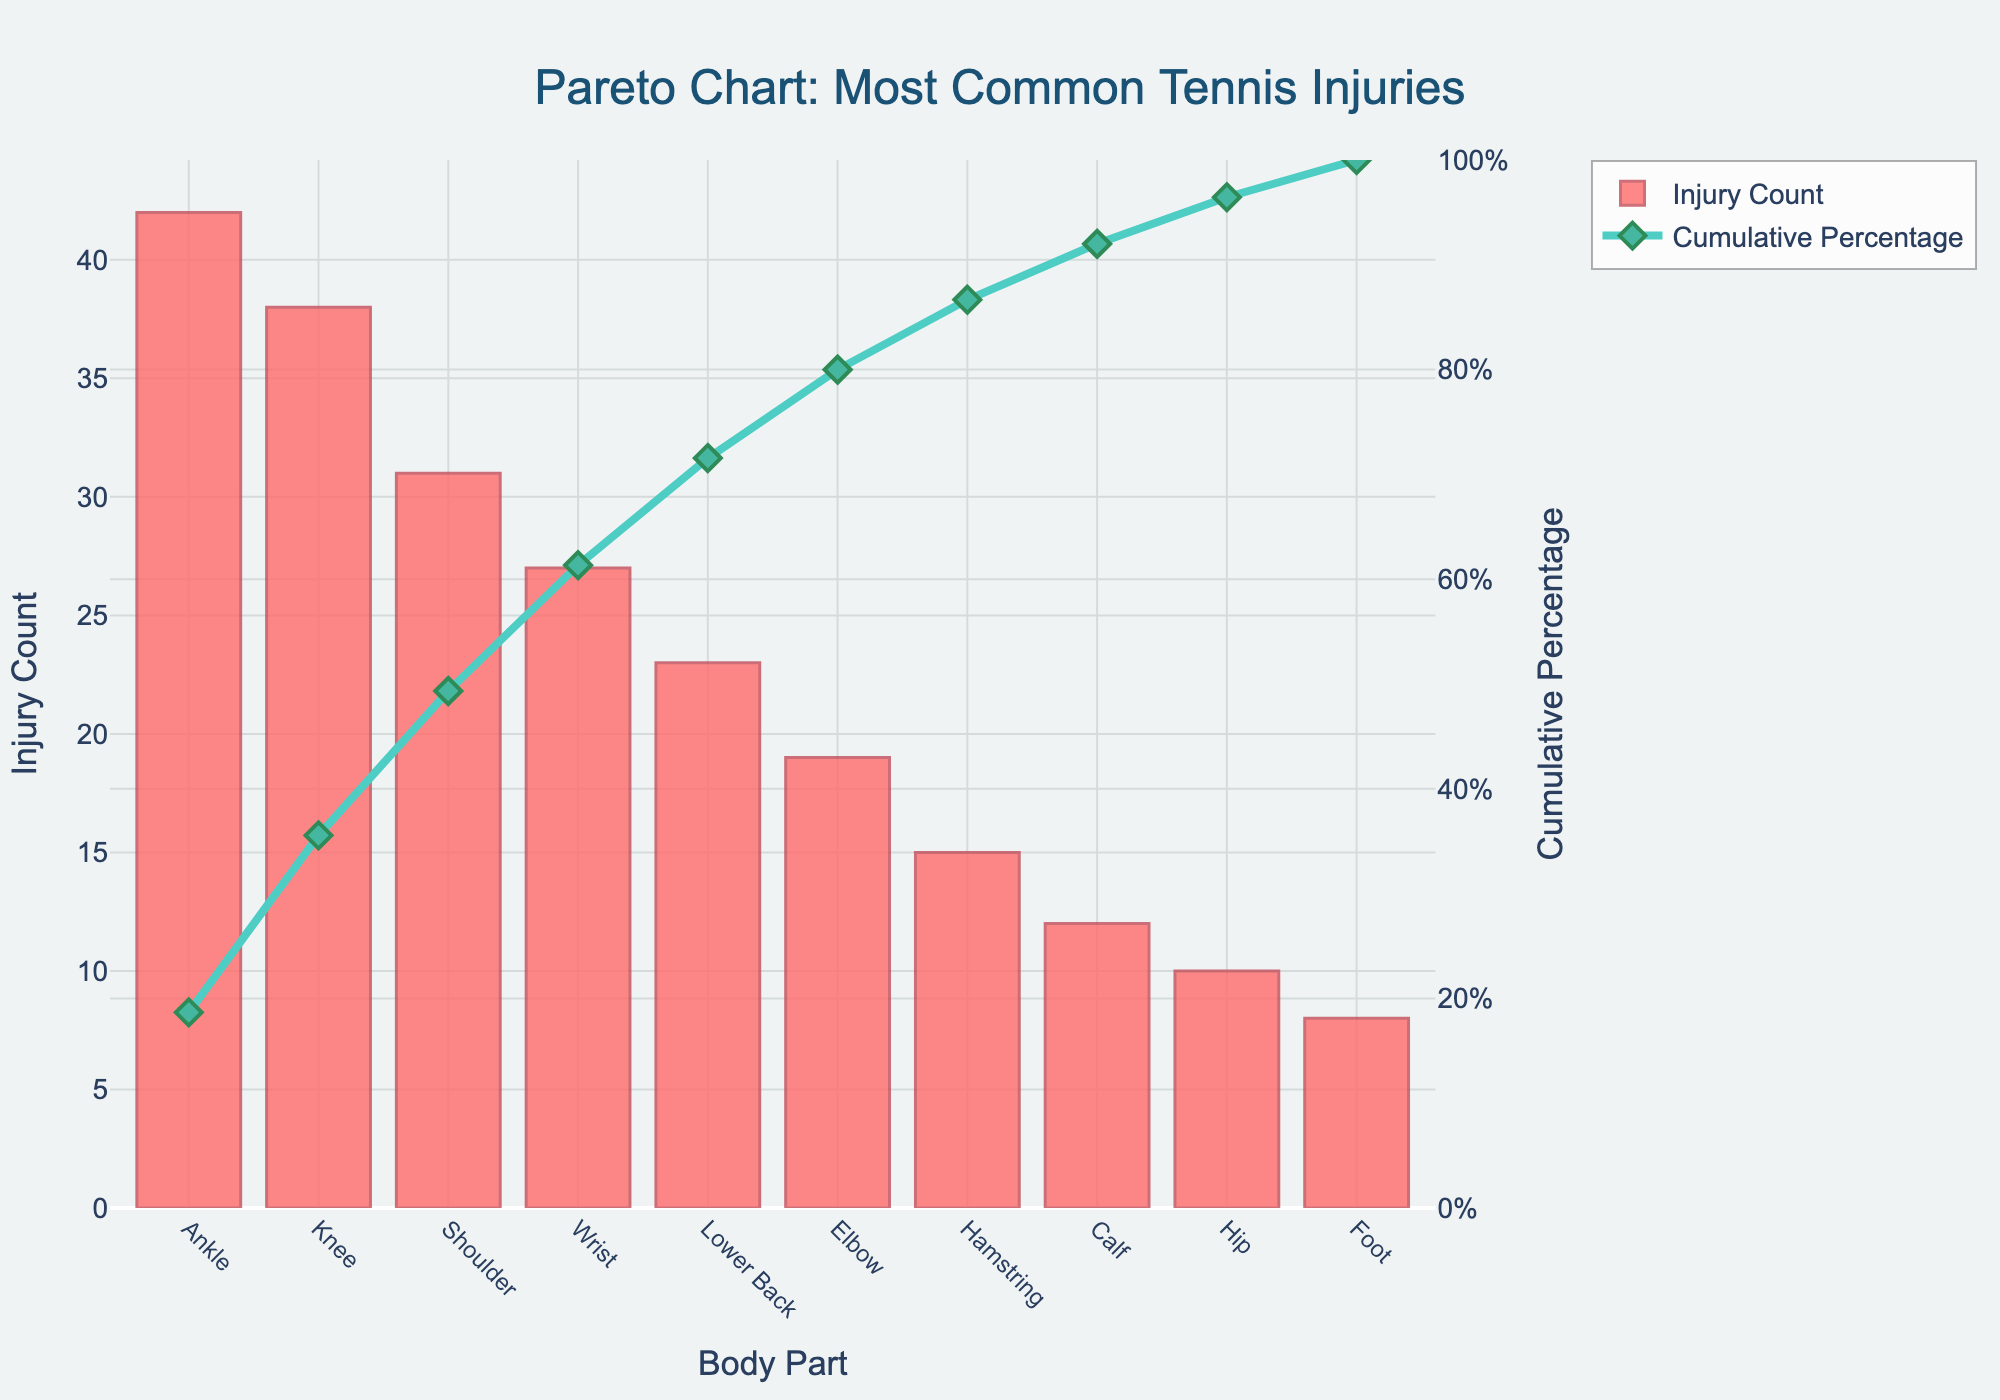What's the title of the chart? The title of the chart is displayed at the top and reads, "Pareto Chart: Most Common Tennis Injuries".
Answer: Pareto Chart: Most Common Tennis Injuries What are the units on the y-axis on the left side? The y-axis on the left side shows the "Injury Count", which represents the number of injuries for each body part.
Answer: Injury Count Which body part has the highest injury count? The body part with the highest bar on the chart represents the highest injury count. In this case, it is the ankle.
Answer: Ankle Which body part is the third most common site for injuries? To find the third most common injury site, look for the third highest bar in descending order. Here, it is the shoulder.
Answer: Shoulder At what cumulative percentage does the elbow injury fall? Locate the data point for the elbow injury and track it to the cumulative percentage line. This value corresponds to approximately 79%.
Answer: ~79% What is the total injury count for the top three body parts? Sum the injury counts of the top three body parts (Ankle, Knee, and Shoulder): 42 + 38 + 31 = 111.
Answer: 111 Is the cumulative percentage line always increasing? The cumulative percentage line always increases or stays flat as it accumulates the percentage of injuries from each body part until it reaches 100%.
Answer: Yes Does the cumulative percentage reach 100% at the last data point? The cumulative percentage line should indeed reach 100% at the last body part due to the sum of all injury counts.
Answer: Yes Which body parts have injury counts less than 20? Examine the bars with heights less than 20 on the chart: Elbow, Hamstring, Calf, Hip, Foot.
Answer: Elbow, Hamstring, Calf, Hip, Foot By how much does the injury count for the knee exceed that of the calf? Subtract the calf injury count from the knee injury count: 38 - 12 = 26.
Answer: 26 